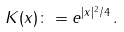Convert formula to latex. <formula><loc_0><loc_0><loc_500><loc_500>K ( x ) \colon = e ^ { | x | ^ { 2 } / 4 } \, .</formula> 